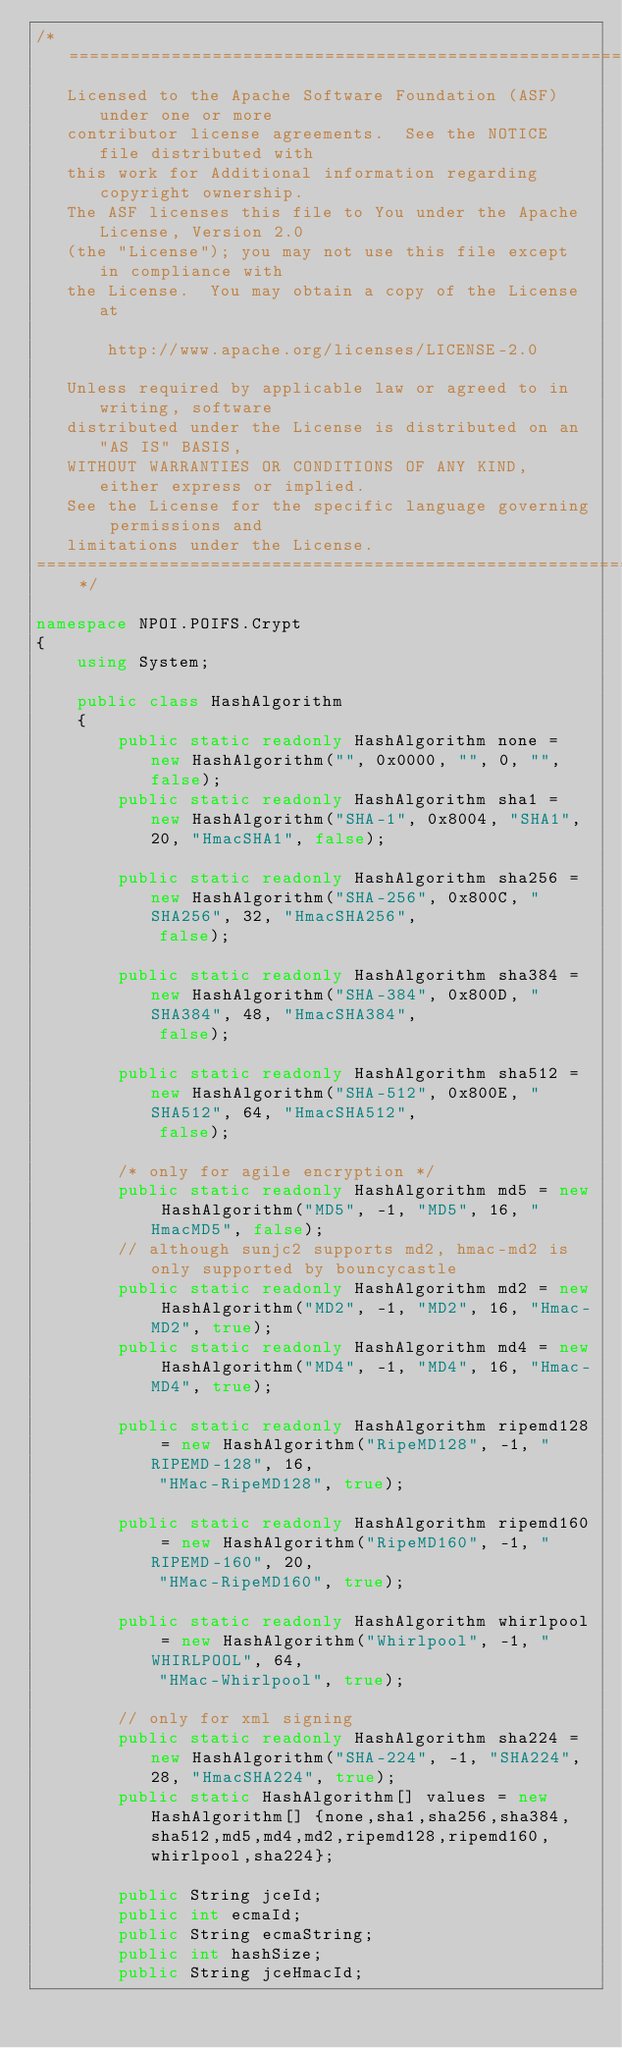<code> <loc_0><loc_0><loc_500><loc_500><_C#_>/* ====================================================================
   Licensed to the Apache Software Foundation (ASF) under one or more
   contributor license agreements.  See the NOTICE file distributed with
   this work for Additional information regarding copyright ownership.
   The ASF licenses this file to You under the Apache License, Version 2.0
   (the "License"); you may not use this file except in compliance with
   the License.  You may obtain a copy of the License at

       http://www.apache.org/licenses/LICENSE-2.0

   Unless required by applicable law or agreed to in writing, software
   distributed under the License is distributed on an "AS IS" BASIS,
   WITHOUT WARRANTIES OR CONDITIONS OF ANY KIND, either express or implied.
   See the License for the specific language governing permissions and
   limitations under the License.
==================================================================== */

namespace NPOI.POIFS.Crypt
{
    using System;

    public class HashAlgorithm
    {
        public static readonly HashAlgorithm none = new HashAlgorithm("", 0x0000, "", 0, "", false);
        public static readonly HashAlgorithm sha1 = new HashAlgorithm("SHA-1", 0x8004, "SHA1", 20, "HmacSHA1", false);

        public static readonly HashAlgorithm sha256 = new HashAlgorithm("SHA-256", 0x800C, "SHA256", 32, "HmacSHA256",
            false);

        public static readonly HashAlgorithm sha384 = new HashAlgorithm("SHA-384", 0x800D, "SHA384", 48, "HmacSHA384",
            false);

        public static readonly HashAlgorithm sha512 = new HashAlgorithm("SHA-512", 0x800E, "SHA512", 64, "HmacSHA512",
            false);

        /* only for agile encryption */
        public static readonly HashAlgorithm md5 = new HashAlgorithm("MD5", -1, "MD5", 16, "HmacMD5", false);
        // although sunjc2 supports md2, hmac-md2 is only supported by bouncycastle
        public static readonly HashAlgorithm md2 = new HashAlgorithm("MD2", -1, "MD2", 16, "Hmac-MD2", true);
        public static readonly HashAlgorithm md4 = new HashAlgorithm("MD4", -1, "MD4", 16, "Hmac-MD4", true);

        public static readonly HashAlgorithm ripemd128 = new HashAlgorithm("RipeMD128", -1, "RIPEMD-128", 16,
            "HMac-RipeMD128", true);

        public static readonly HashAlgorithm ripemd160 = new HashAlgorithm("RipeMD160", -1, "RIPEMD-160", 20,
            "HMac-RipeMD160", true);

        public static readonly HashAlgorithm whirlpool = new HashAlgorithm("Whirlpool", -1, "WHIRLPOOL", 64,
            "HMac-Whirlpool", true);

        // only for xml signing
        public static readonly HashAlgorithm sha224 = new HashAlgorithm("SHA-224", -1, "SHA224", 28, "HmacSHA224", true);
        public static HashAlgorithm[] values = new HashAlgorithm[] {none,sha1,sha256,sha384,sha512,md5,md4,md2,ripemd128,ripemd160,whirlpool,sha224};

        public String jceId;
        public int ecmaId;
        public String ecmaString;
        public int hashSize;
        public String jceHmacId;</code> 